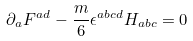Convert formula to latex. <formula><loc_0><loc_0><loc_500><loc_500>\partial _ { a } F ^ { a d } - \frac { m } { 6 } \epsilon ^ { a b c d } H _ { a b c } = 0</formula> 